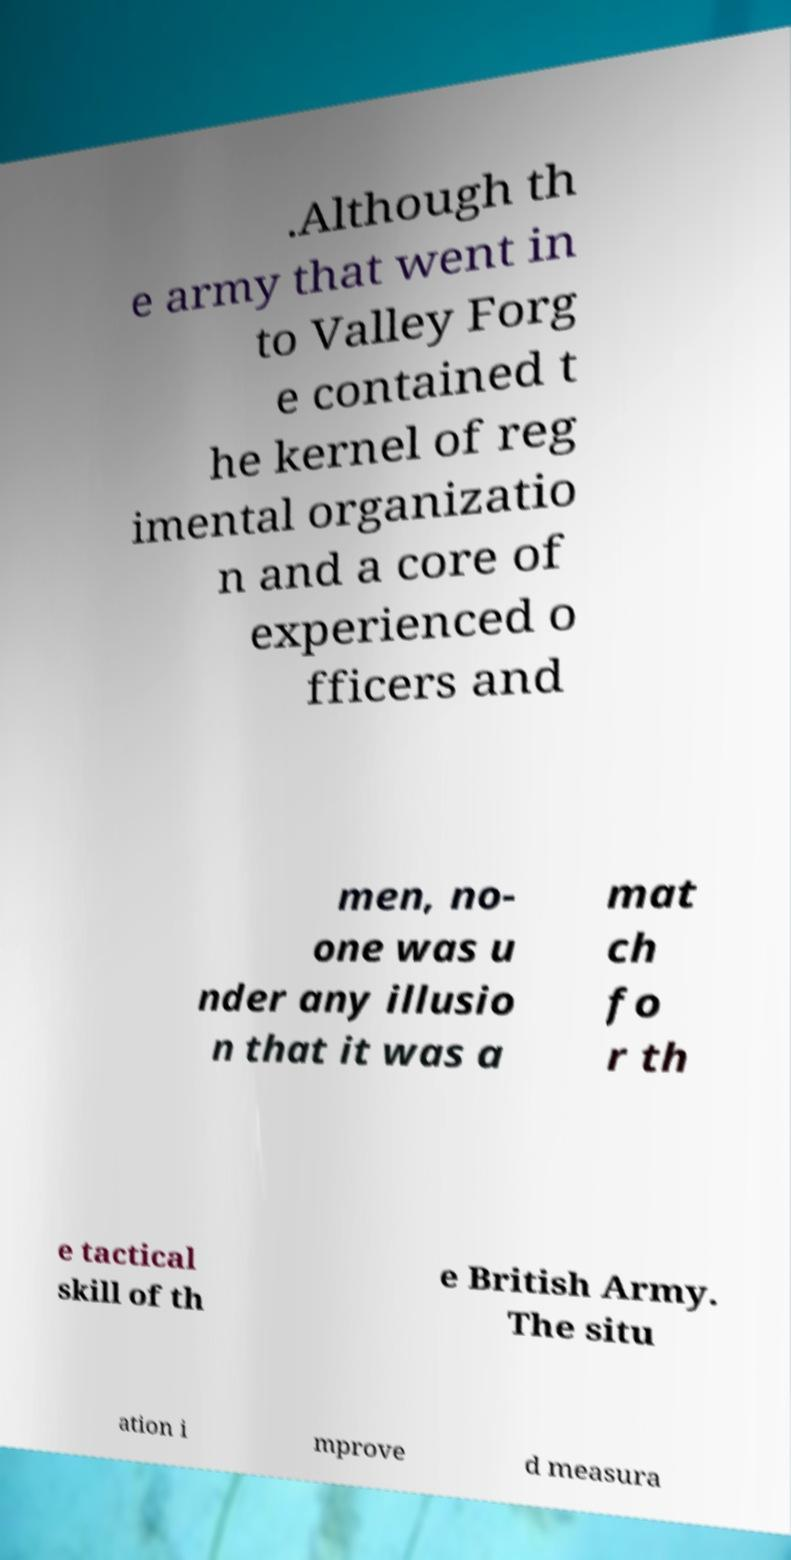Please identify and transcribe the text found in this image. .Although th e army that went in to Valley Forg e contained t he kernel of reg imental organizatio n and a core of experienced o fficers and men, no- one was u nder any illusio n that it was a mat ch fo r th e tactical skill of th e British Army. The situ ation i mprove d measura 